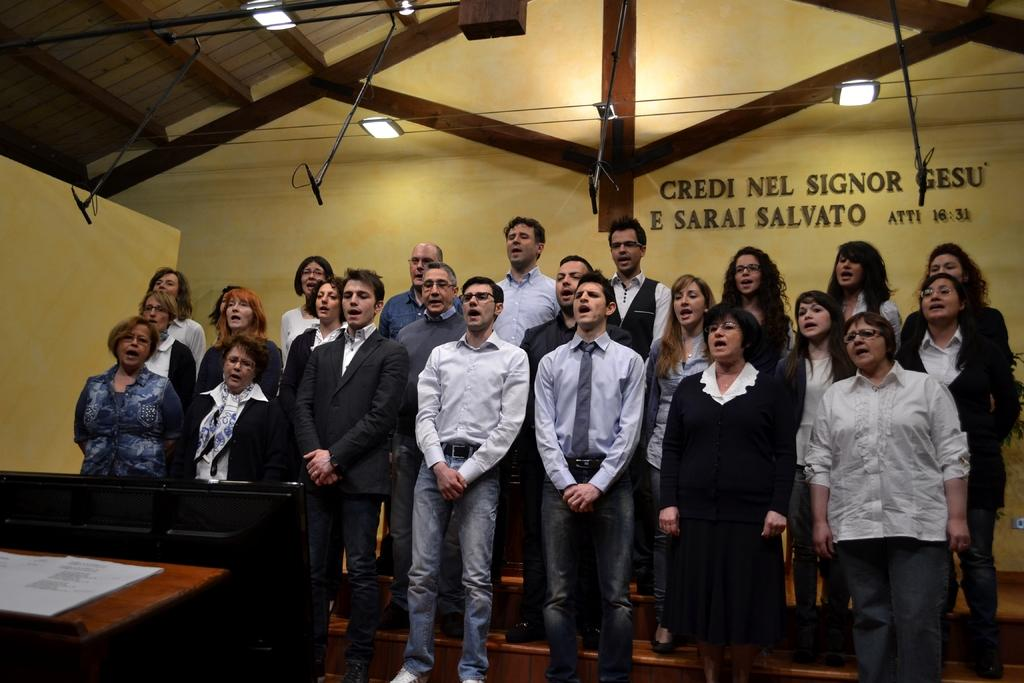What are the people in the image doing? The men and women in the image are standing on the stairs. What type of lighting is present in the image? There are electric lights in the image. What can be seen on the wall in the image? There is text on the wall. What object is on the table in the image? There is a book on a table in the image. What is the taste of the stem in the image? There is no stem present in the image, so it is not possible to determine its taste. 